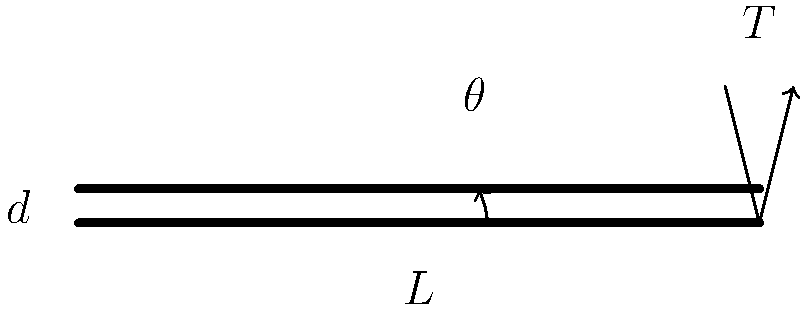A solid steel shaft with a diameter $d = 50$ mm and length $L = 2$ m is subjected to a torque $T = 5000$ N⋅m. Given that the shear modulus of steel is $G = 80$ GPa, determine the angle of twist $\theta$ (in radians) at the free end of the shaft using MATLAB. Round your answer to four decimal places. To solve this problem, we'll use the torsion formula and implement it in MATLAB. Here's a step-by-step approach:

1) The torsion formula for a solid circular shaft is:

   $$\theta = \frac{TL}{JG}$$

   where:
   $\theta$ is the angle of twist in radians
   $T$ is the applied torque
   $L$ is the length of the shaft
   $J$ is the polar moment of inertia
   $G$ is the shear modulus

2) For a solid circular shaft, the polar moment of inertia $J$ is given by:

   $$J = \frac{\pi d^4}{32}$$

3) Now, let's implement this in MATLAB:

   ```matlab
   % Given values
   T = 5000;    % Torque in N⋅m
   L = 2;       % Length in m
   d = 0.05;    % Diameter in m
   G = 80e9;    % Shear modulus in Pa

   % Calculate polar moment of inertia
   J = pi * d^4 / 32;

   % Calculate angle of twist
   theta = (T * L) / (J * G);

   % Display result rounded to 4 decimal places
   fprintf('Angle of twist: %.4f radians\n', theta);
   ```

4) Running this MATLAB script would give us the result.

The angle of twist calculated using this method is approximately 0.1273 radians.
Answer: 0.1273 radians 